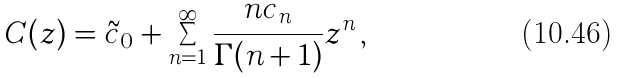<formula> <loc_0><loc_0><loc_500><loc_500>C ( z ) = { \tilde { c } _ { 0 } } + \sum _ { n = 1 } ^ { \infty } \frac { n c _ { n } } { \Gamma ( n + 1 ) } z ^ { n } \, ,</formula> 